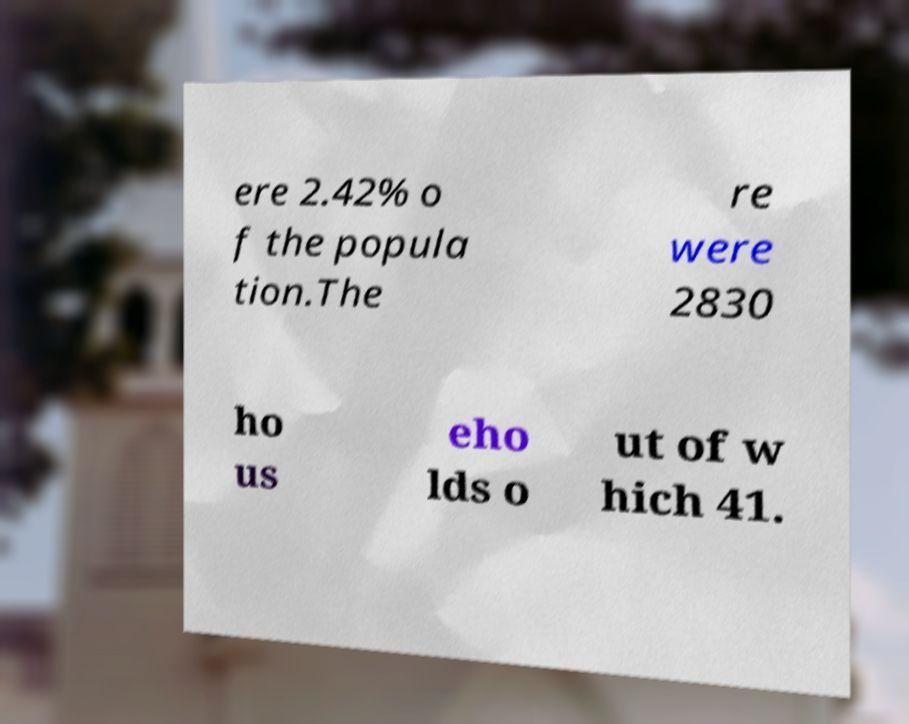Please read and relay the text visible in this image. What does it say? ere 2.42% o f the popula tion.The re were 2830 ho us eho lds o ut of w hich 41. 